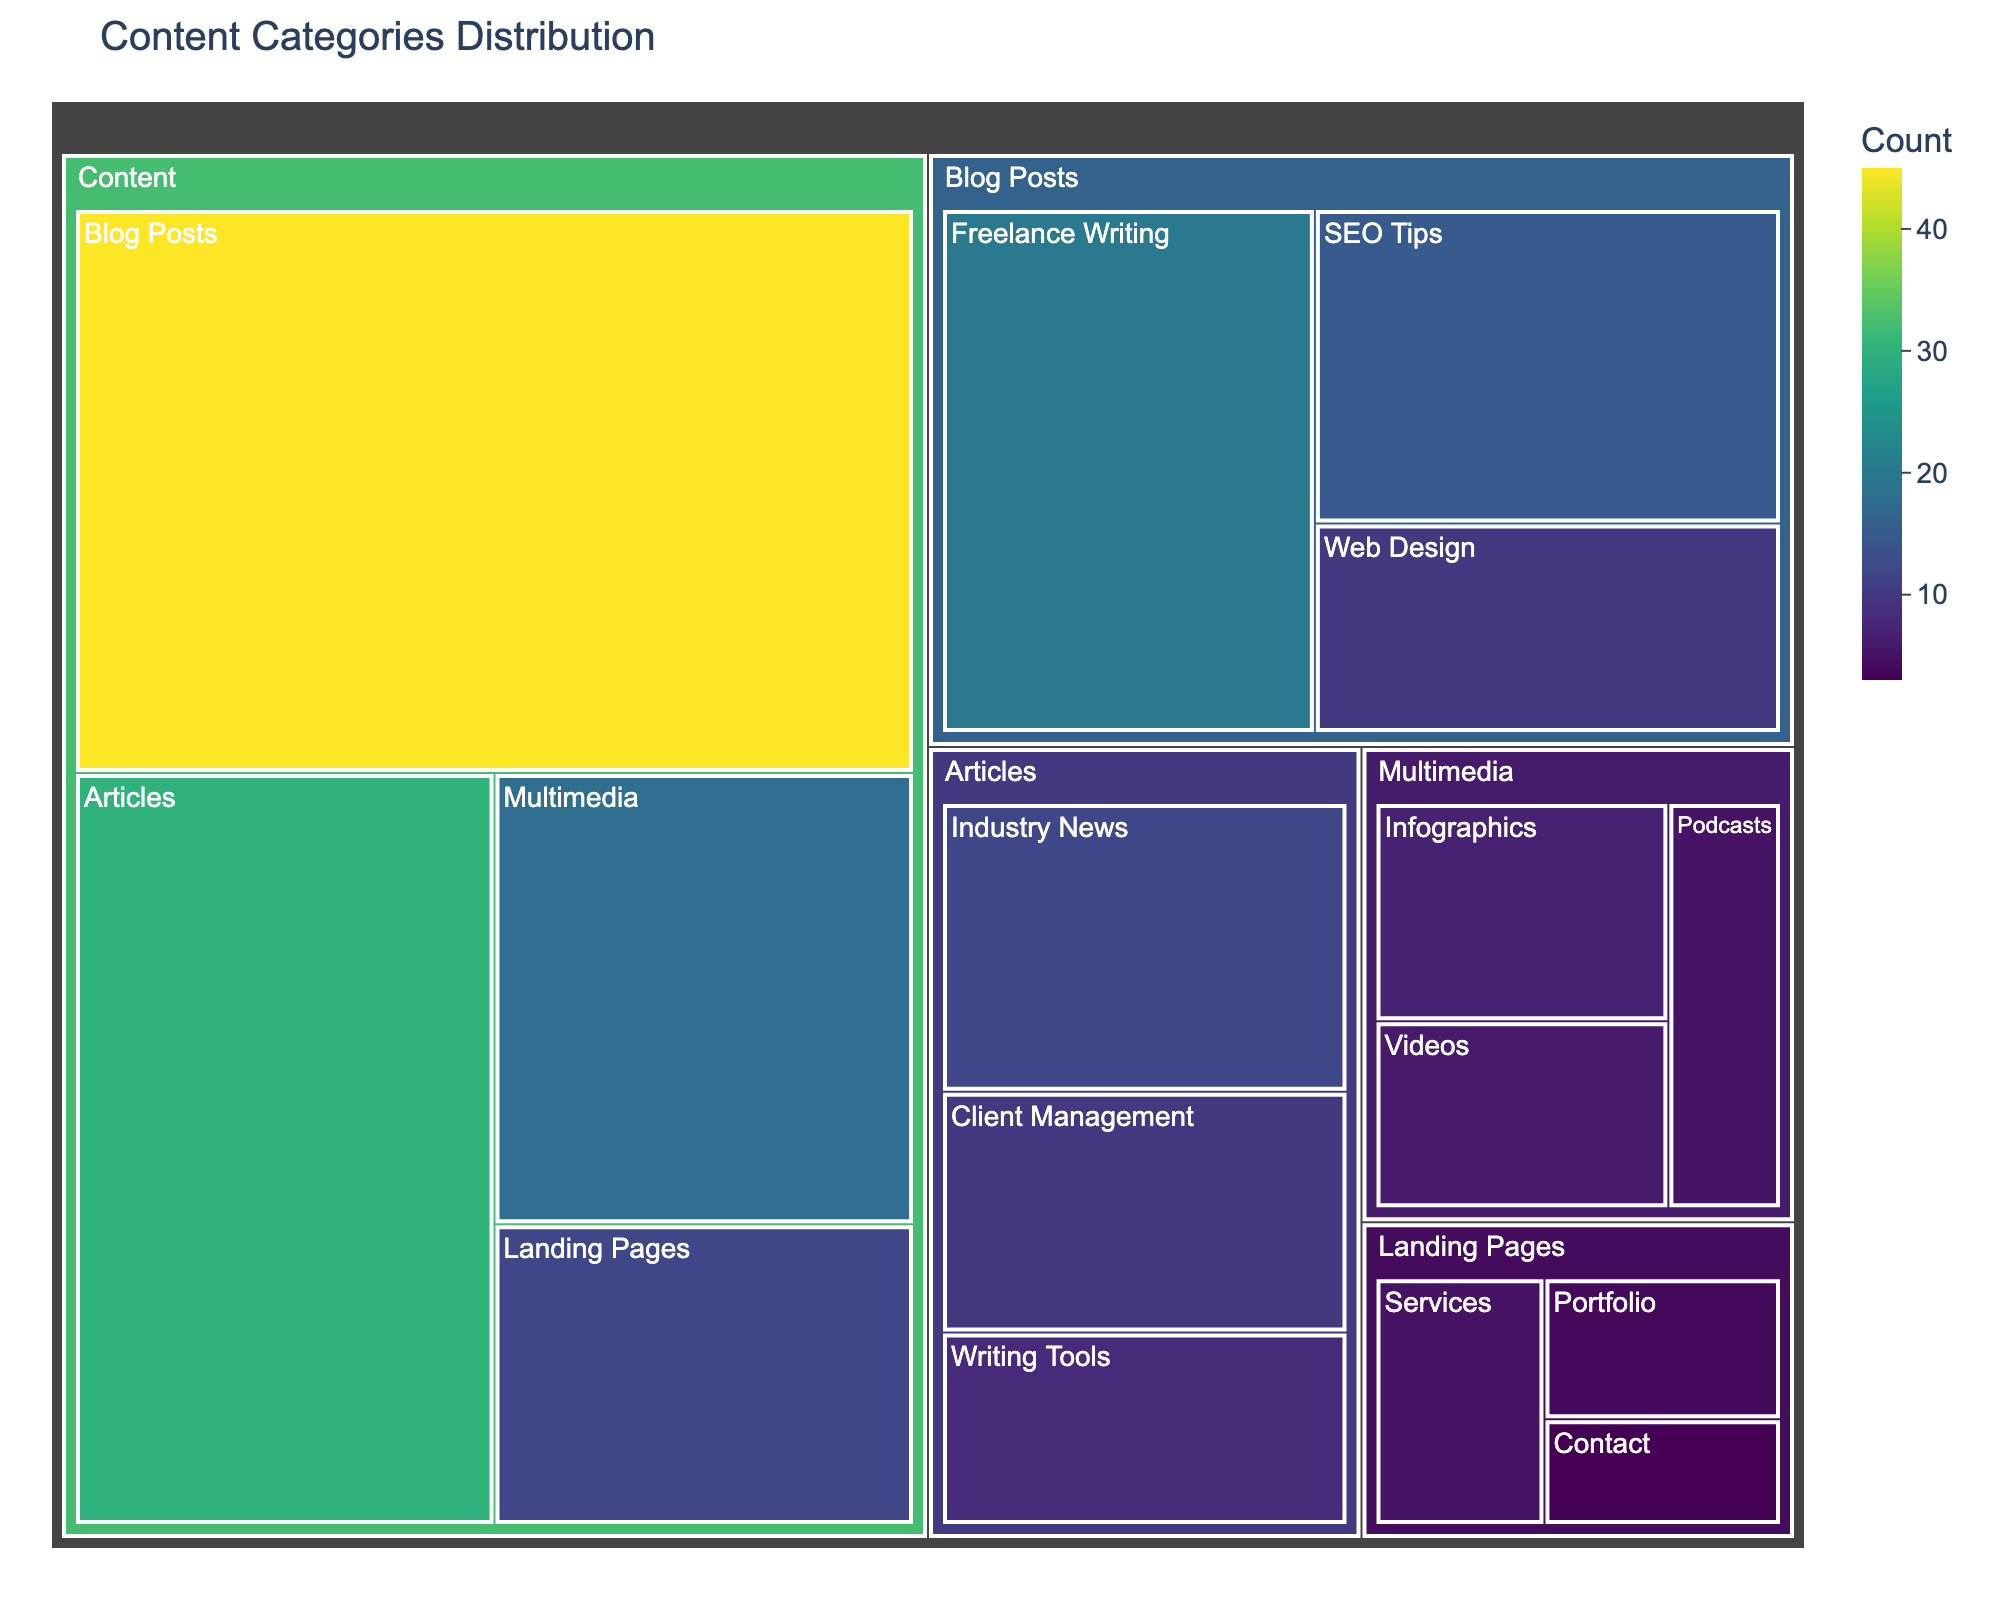How many blog posts are there in total? The blog posts section contains three subcategories: SEO Tips (15), Freelance Writing (20), and Web Design (10). Adding these together gives 15 + 20 + 10 = 45.
Answer: 45 Which content type has the highest count? The counts for each main content type are as follows: Blog Posts (45), Articles (30), Landing Pages (12), and Multimedia (18). Blog Posts have the highest count.
Answer: Blog Posts What is the total count of articles related to writing tools and client management? Articles related to Writing Tools have a count of 8, and those related to Client Management have a count of 10. Adding these gives 8 + 10 = 18.
Answer: 18 Which subcategory has the smallest count, and what is it? The counts for each subcategory are: SEO Tips (15), Freelance Writing (20), Web Design (10), Industry News (12), Writing Tools (8), Client Management (10), Services (5), Portfolio (4), Contact (3), Infographics (7), Videos (6), and Podcasts (5). The smallest count is in the Contact subcategory, which is 3.
Answer: Contact, 3 Compare the total number of multimedia items with landing pages. Which is greater and by how much? The total count for Multimedia is 18, and for Landing Pages, it is 12. The difference is 18 - 12 = 6. Multimedia has 6 more items than Landing Pages.
Answer: Multimedia, 6 What’s the total number of content categories mentioned in the treemap? The categories mentioned are Blog Posts, Articles, Landing Pages, and Multimedia. There are a total of 4 content categories.
Answer: 4 Which subcategory in Multimedia has the highest count? Within the Multimedia category, the counts are: Infographics (7), Videos (6), and Podcasts (5). Infographics have the highest count.
Answer: Infographics How many types of articles are there? The articles section includes three types: Industry News, Writing Tools, and Client Management.
Answer: 3 